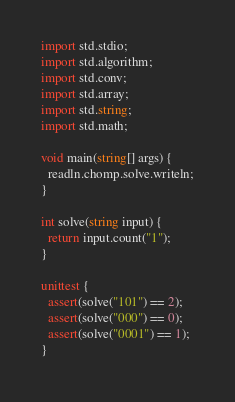<code> <loc_0><loc_0><loc_500><loc_500><_D_>import std.stdio;
import std.algorithm;
import std.conv;
import std.array;
import std.string;
import std.math;

void main(string[] args) {
  readln.chomp.solve.writeln;
}

int solve(string input) {
  return input.count("1");
}

unittest {
  assert(solve("101") == 2);
  assert(solve("000") == 0);
  assert(solve("0001") == 1);
}
</code> 